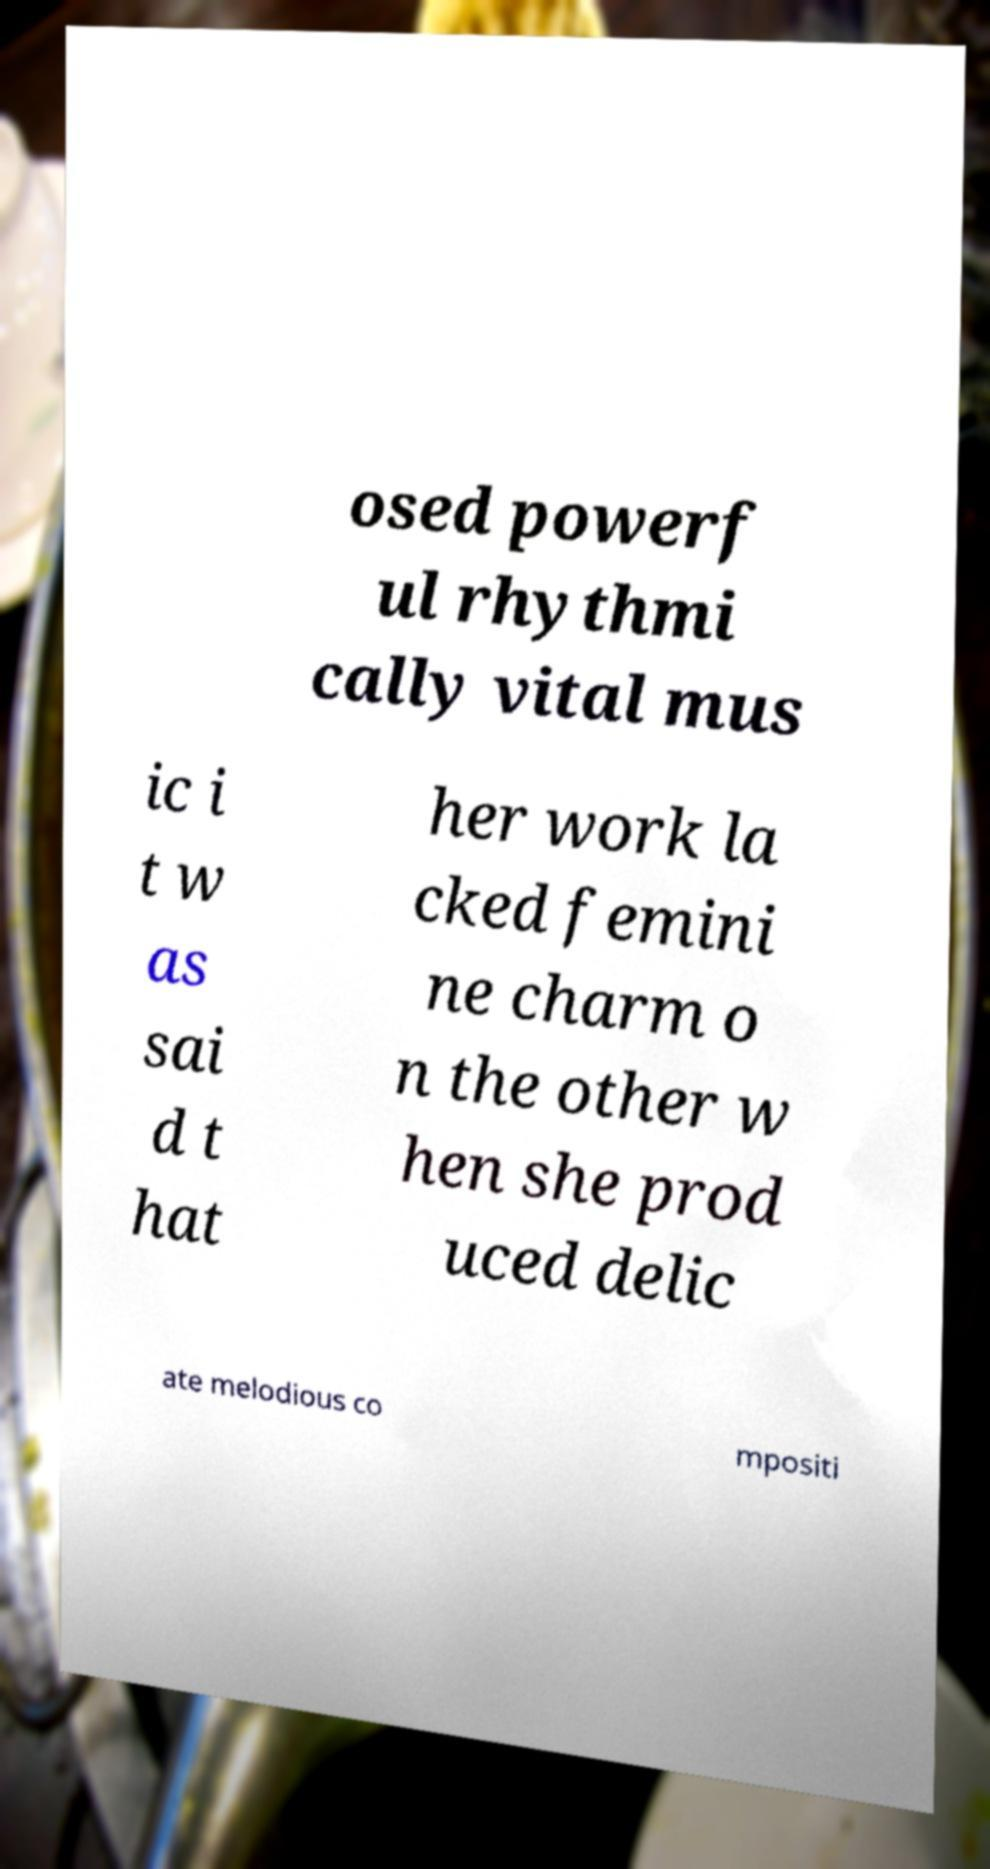Please read and relay the text visible in this image. What does it say? osed powerf ul rhythmi cally vital mus ic i t w as sai d t hat her work la cked femini ne charm o n the other w hen she prod uced delic ate melodious co mpositi 